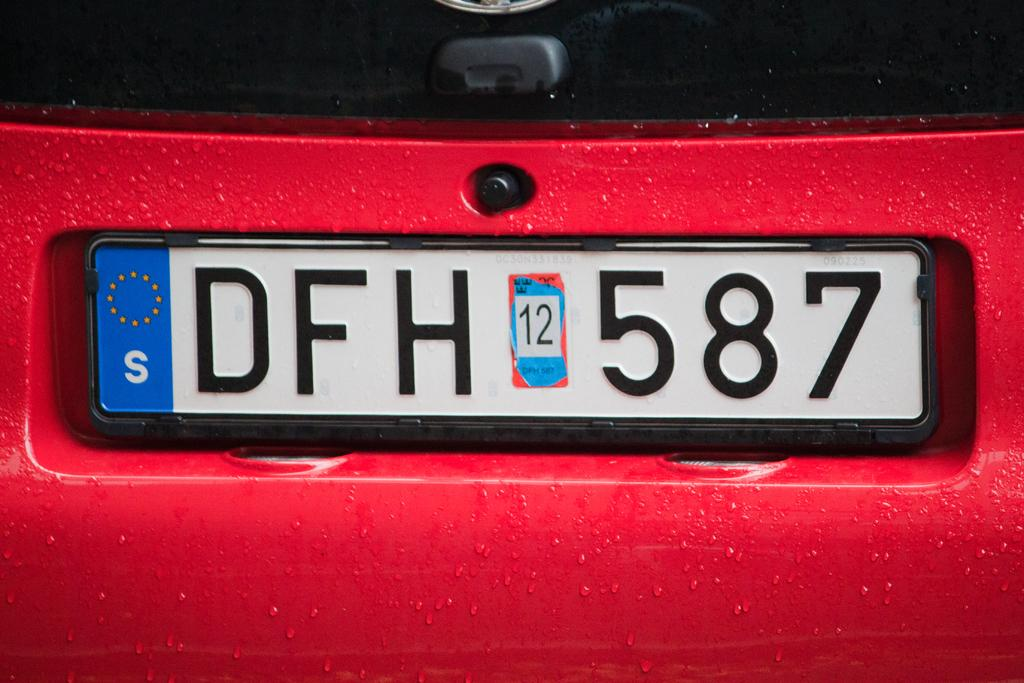<image>
Present a compact description of the photo's key features. License plate with the word DFH 12 587 placed on a red car. 